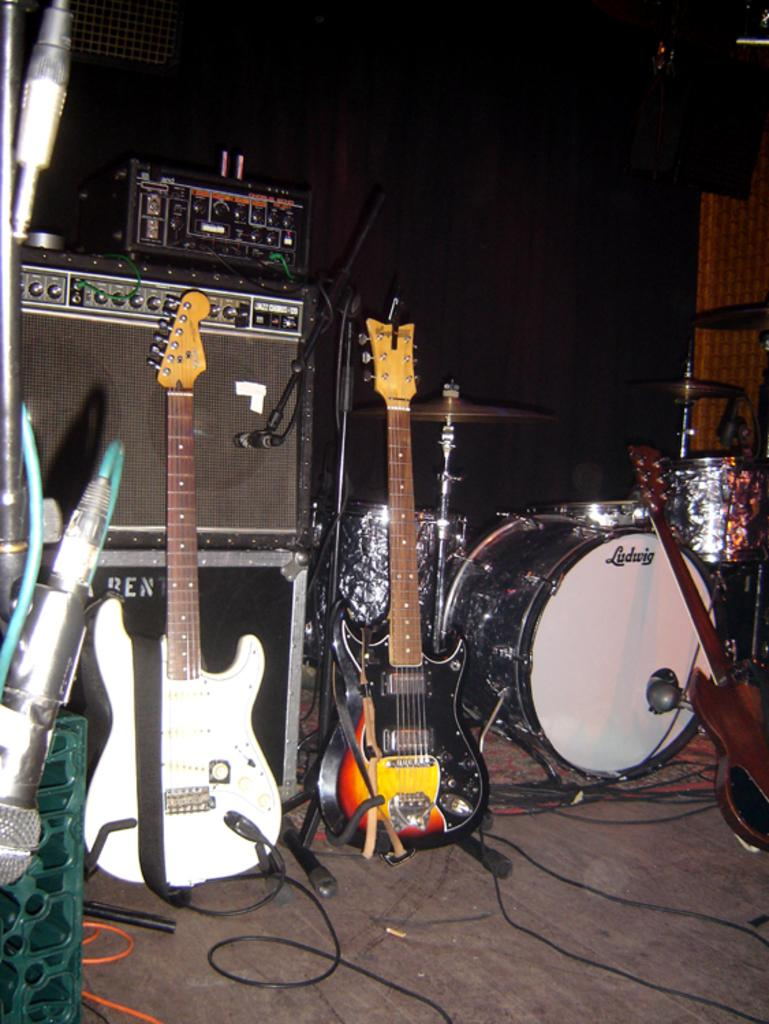What musical instrument can be seen in the image? There is a guitar in the image. What other musical instrument is present in the image? There is a drum in the image. What device might be used for amplifying sound in the image? There is a mic in the image. What type of muscle can be seen flexing near the guitar in the image? There is no muscle visible in the image; it features a guitar, a drum, and a mic. What phase of the moon is depicted in the image? There is no moon present in the image. 